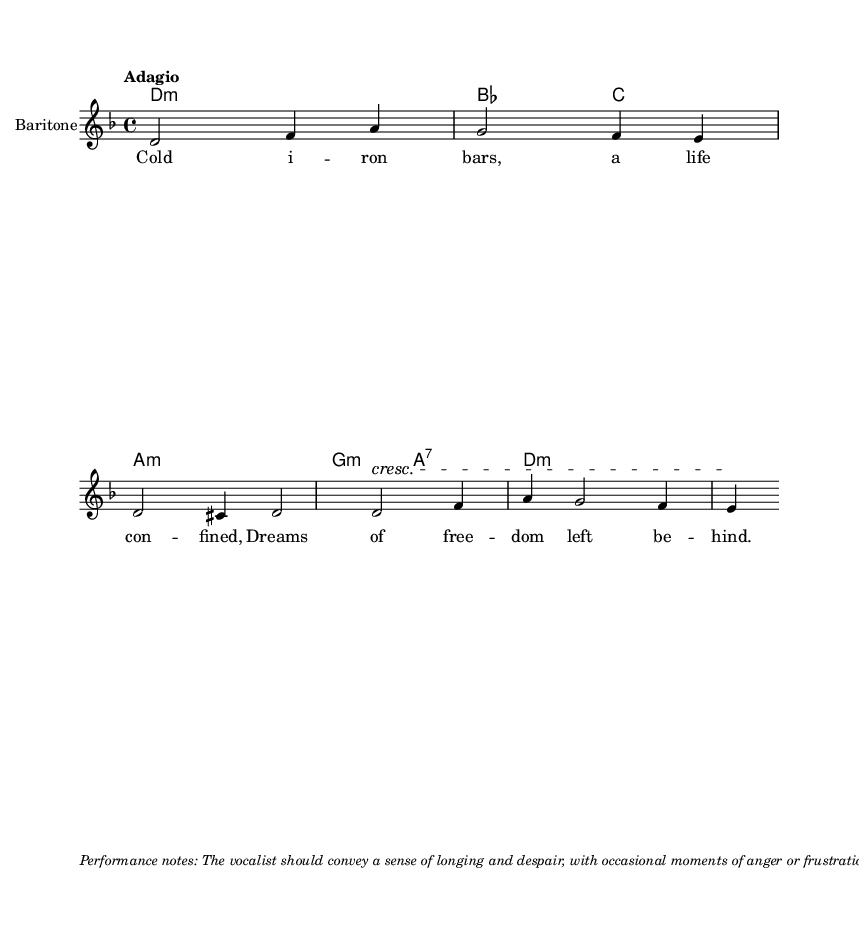What is the key signature of this music? The key signature listed in the global settings is D minor, which has one flat (B flat). This is indicated at the beginning of the score.
Answer: D minor What is the time signature of this music? The time signature specified in the global settings is 4/4, meaning there are four beats in a measure and a quarter note gets one beat. This is also indicated at the start of the score.
Answer: 4/4 What is the tempo marking of this music? The tempo indicated in the score is "Adagio," which typically means slow and leisurely. This is written clearly under the global settings.
Answer: Adagio How many measures are in the melody? Counting the measures from the melody section, there are a total of 5 measures. This can be seen in the melody notation before the lyrics.
Answer: 5 What is the vocal part designated for this score? The score specifies "Baritone" as the instrument name for the vocal part, which indicates the range of the singer. This designation appears in the staff settings.
Answer: Baritone Describe the emotional tone suggested for the performance. The performance notes describe the emotional tone as conveying longing and despair, with moments of anger or frustration. This guidance is provided in the markup section of the code.
Answer: Longing and despair 